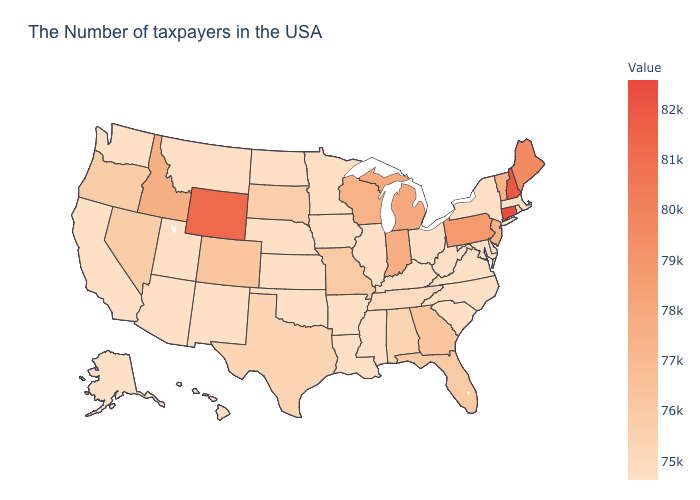Does Georgia have the highest value in the South?
Short answer required. Yes. Which states hav the highest value in the Northeast?
Be succinct. Connecticut. Does Connecticut have a higher value than Oklahoma?
Concise answer only. Yes. 